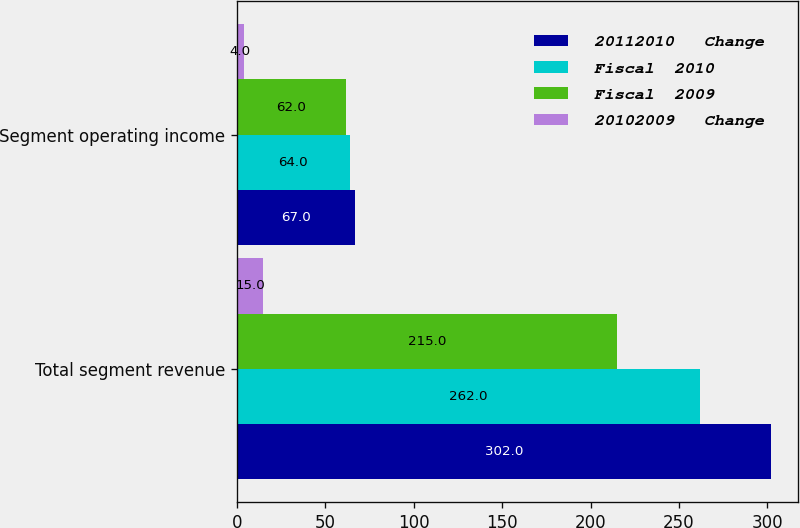Convert chart. <chart><loc_0><loc_0><loc_500><loc_500><stacked_bar_chart><ecel><fcel>Total segment revenue<fcel>Segment operating income<nl><fcel>20112010   Change<fcel>302<fcel>67<nl><fcel>Fiscal  2010<fcel>262<fcel>64<nl><fcel>Fiscal  2009<fcel>215<fcel>62<nl><fcel>20102009   Change<fcel>15<fcel>4<nl></chart> 